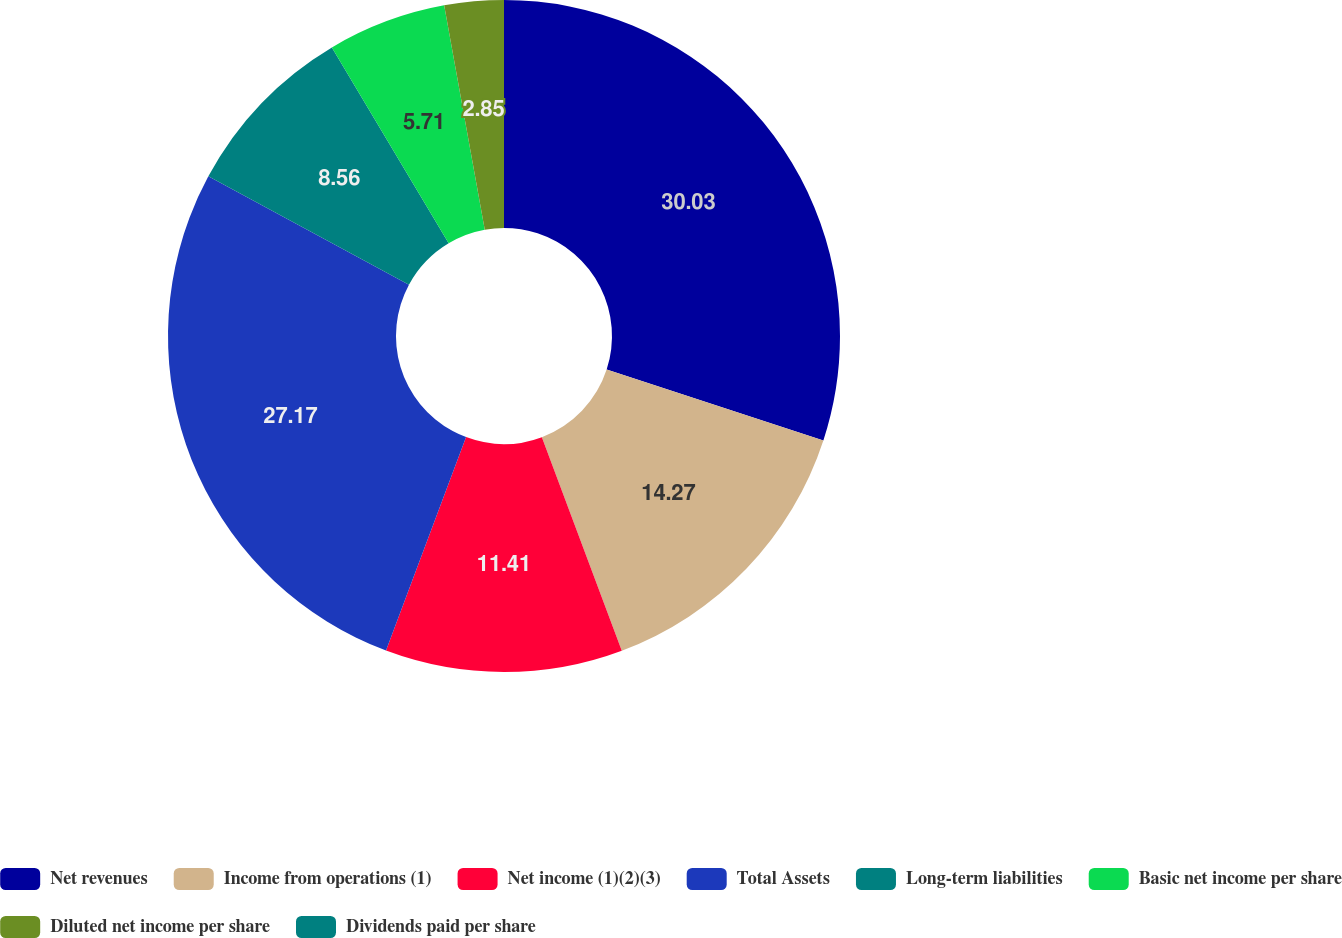Convert chart. <chart><loc_0><loc_0><loc_500><loc_500><pie_chart><fcel>Net revenues<fcel>Income from operations (1)<fcel>Net income (1)(2)(3)<fcel>Total Assets<fcel>Long-term liabilities<fcel>Basic net income per share<fcel>Diluted net income per share<fcel>Dividends paid per share<nl><fcel>30.03%<fcel>14.27%<fcel>11.41%<fcel>27.17%<fcel>8.56%<fcel>5.71%<fcel>2.85%<fcel>0.0%<nl></chart> 